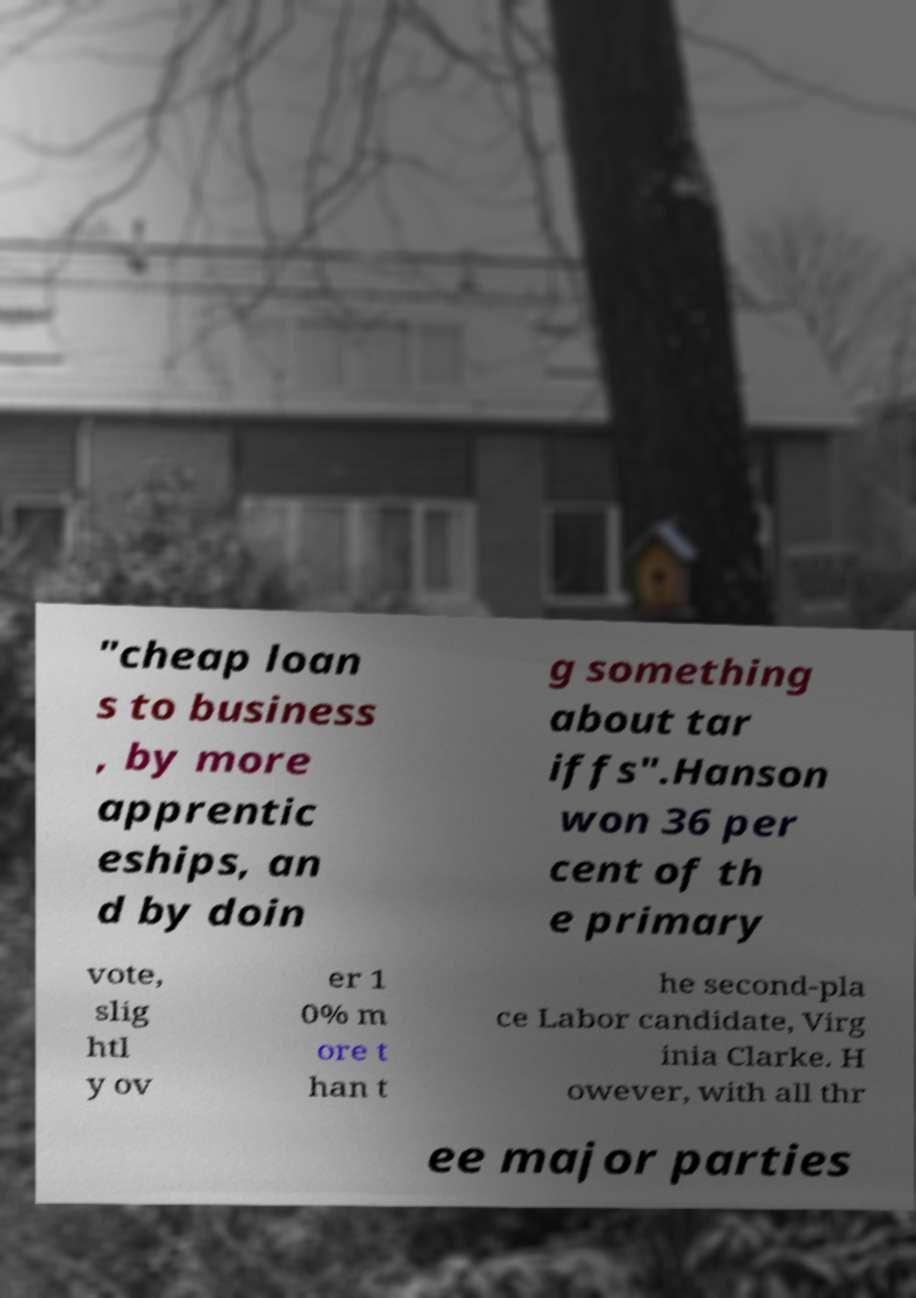Could you extract and type out the text from this image? "cheap loan s to business , by more apprentic eships, an d by doin g something about tar iffs".Hanson won 36 per cent of th e primary vote, slig htl y ov er 1 0% m ore t han t he second-pla ce Labor candidate, Virg inia Clarke. H owever, with all thr ee major parties 